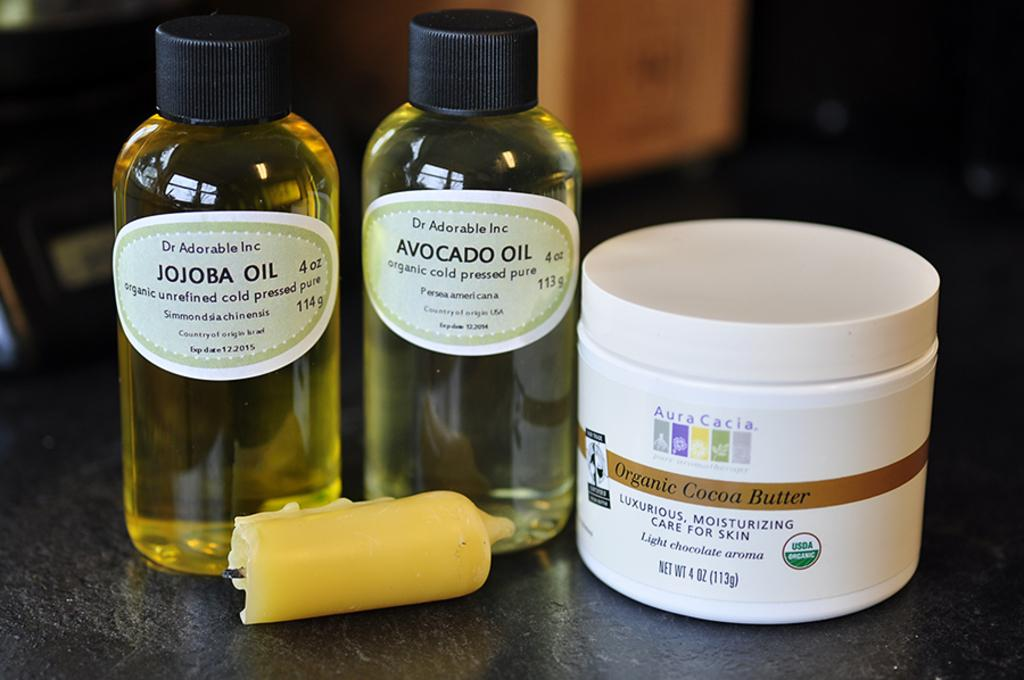<image>
Present a compact description of the photo's key features. Organic Cocoa Butter bottle next to a bottle of Avocado Oil. 